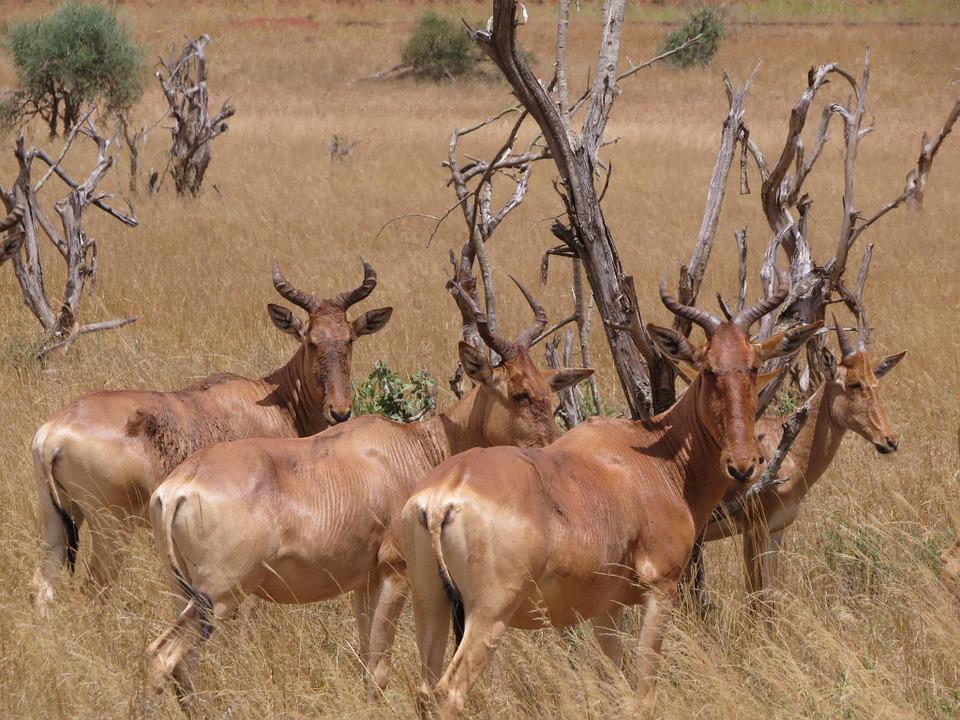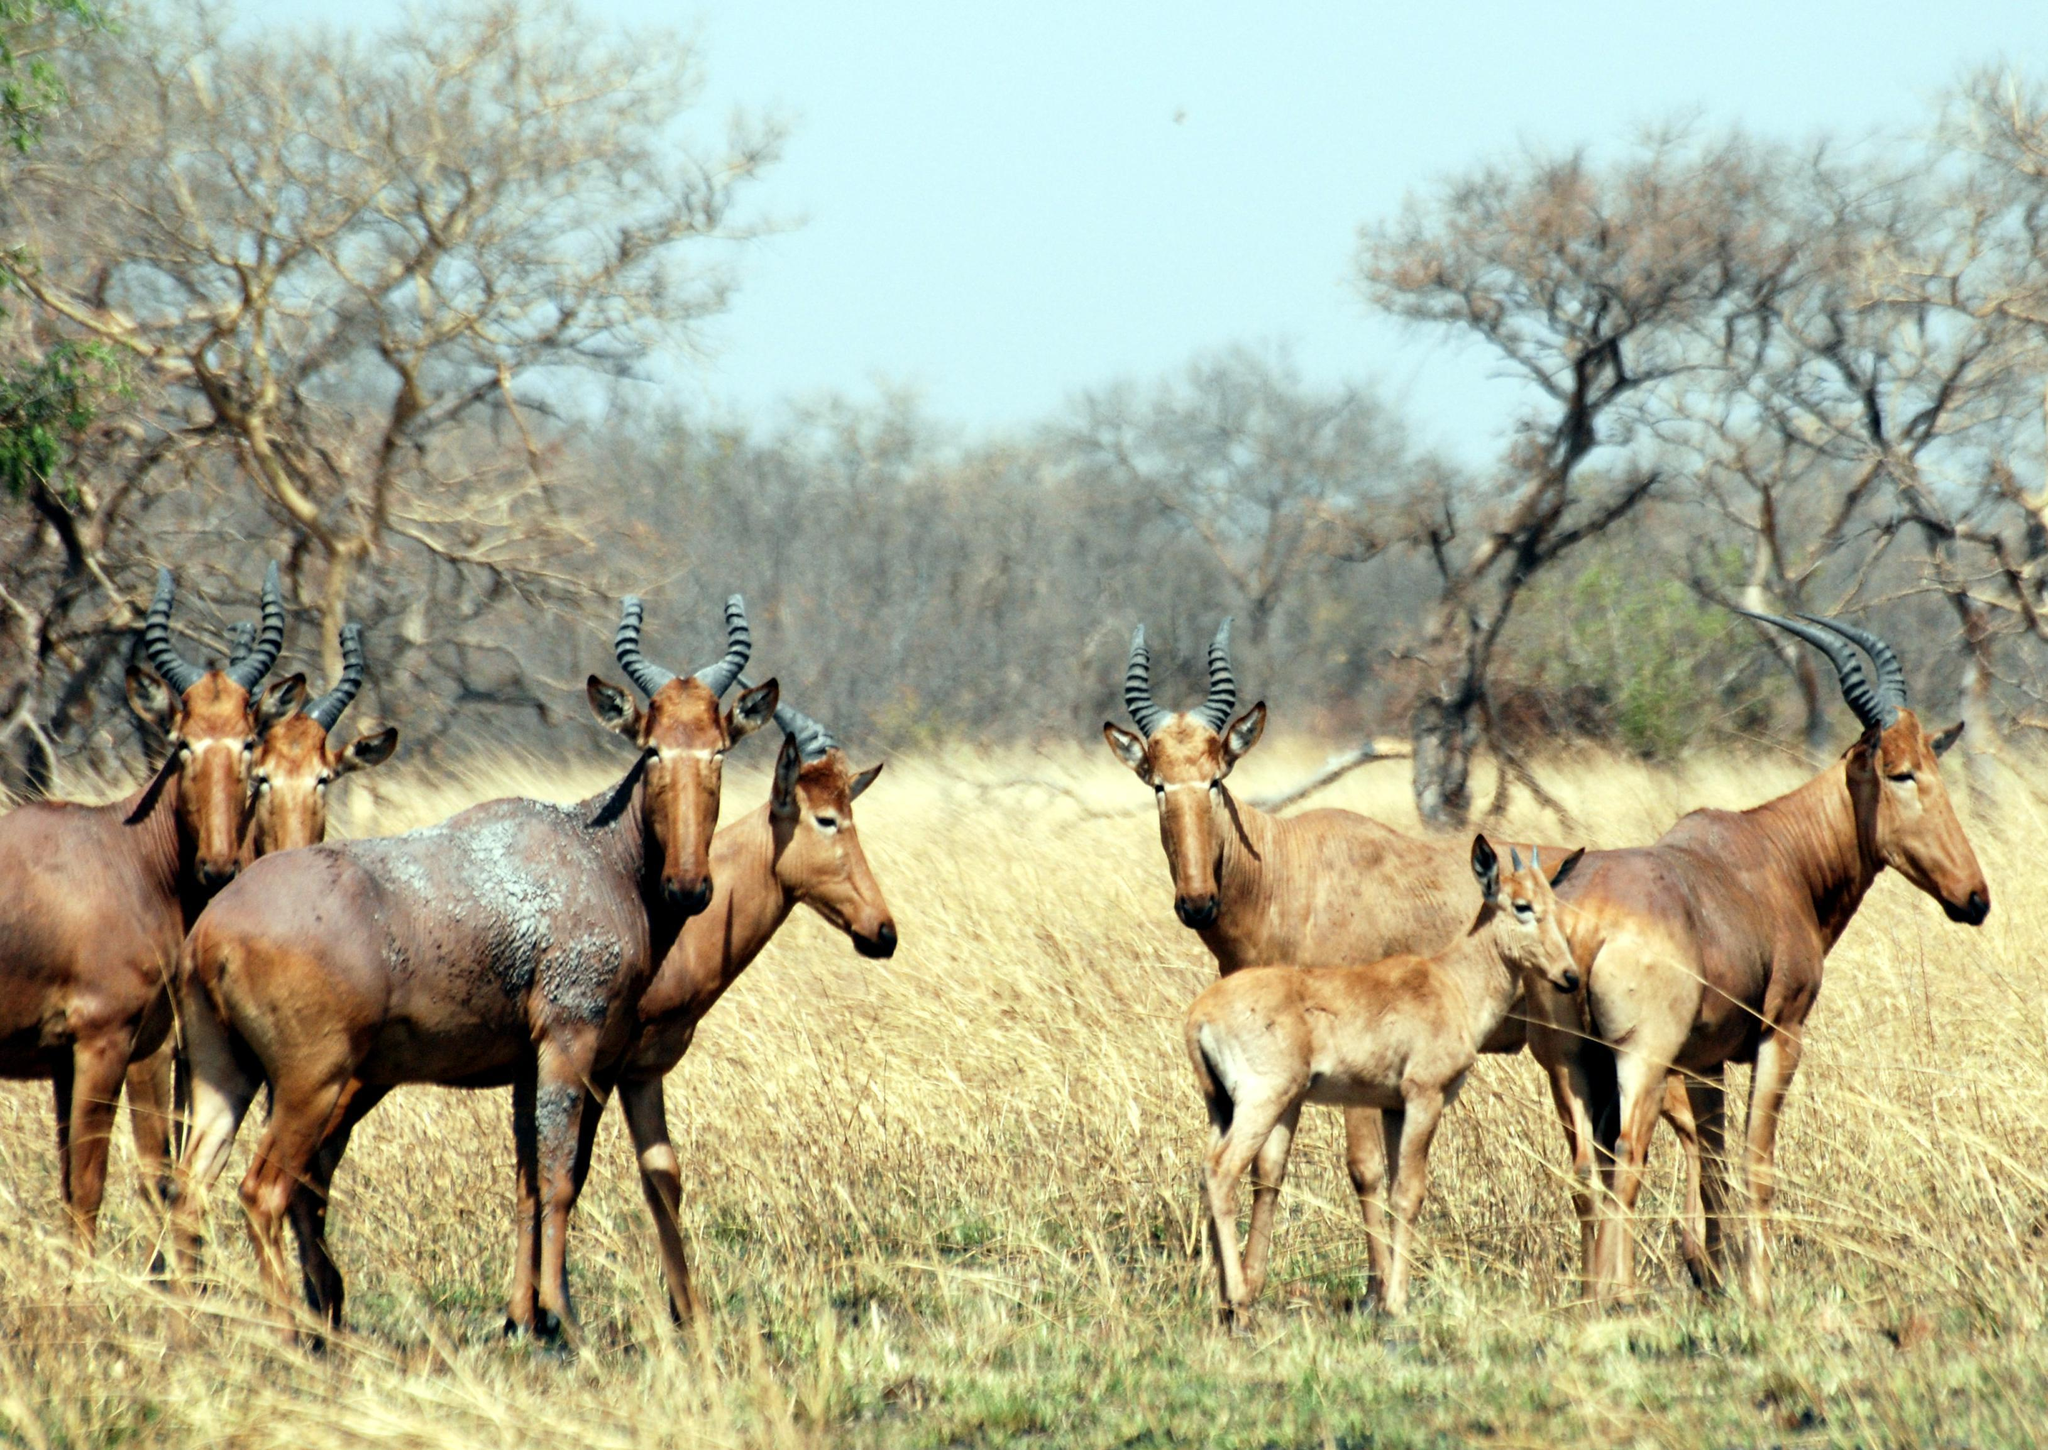The first image is the image on the left, the second image is the image on the right. Evaluate the accuracy of this statement regarding the images: "An image includes a horned animal that is bounding with front legs fully off the ground.". Is it true? Answer yes or no. No. The first image is the image on the left, the second image is the image on the right. Analyze the images presented: Is the assertion "At least one antelope has its front legs int he air." valid? Answer yes or no. No. 